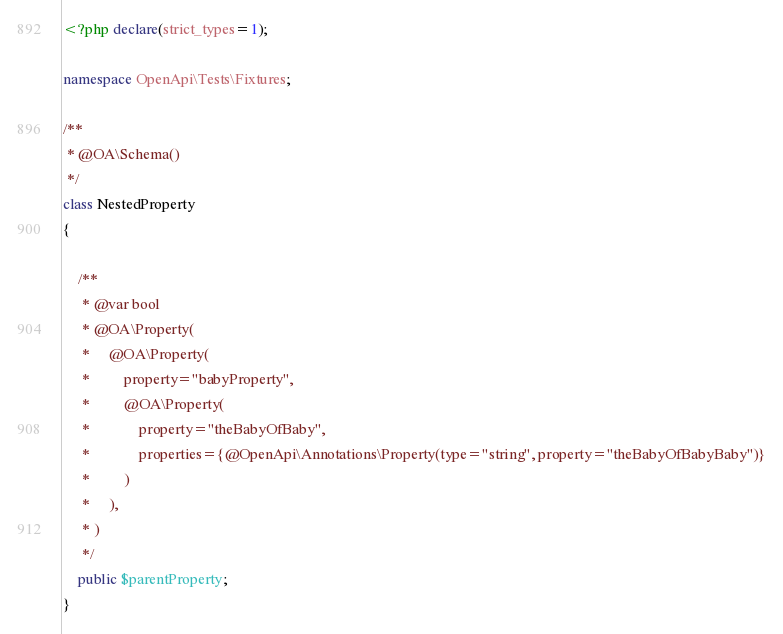Convert code to text. <code><loc_0><loc_0><loc_500><loc_500><_PHP_><?php declare(strict_types=1);

namespace OpenApi\Tests\Fixtures;

/**
 * @OA\Schema()
 */
class NestedProperty
{

    /**
     * @var bool
     * @OA\Property(
     *     @OA\Property(
     *         property="babyProperty",
     *         @OA\Property(
     *             property="theBabyOfBaby",
     *             properties={@OpenApi\Annotations\Property(type="string", property="theBabyOfBabyBaby")}
     *         )
     *     ),
     * )
     */
    public $parentProperty;
}
</code> 